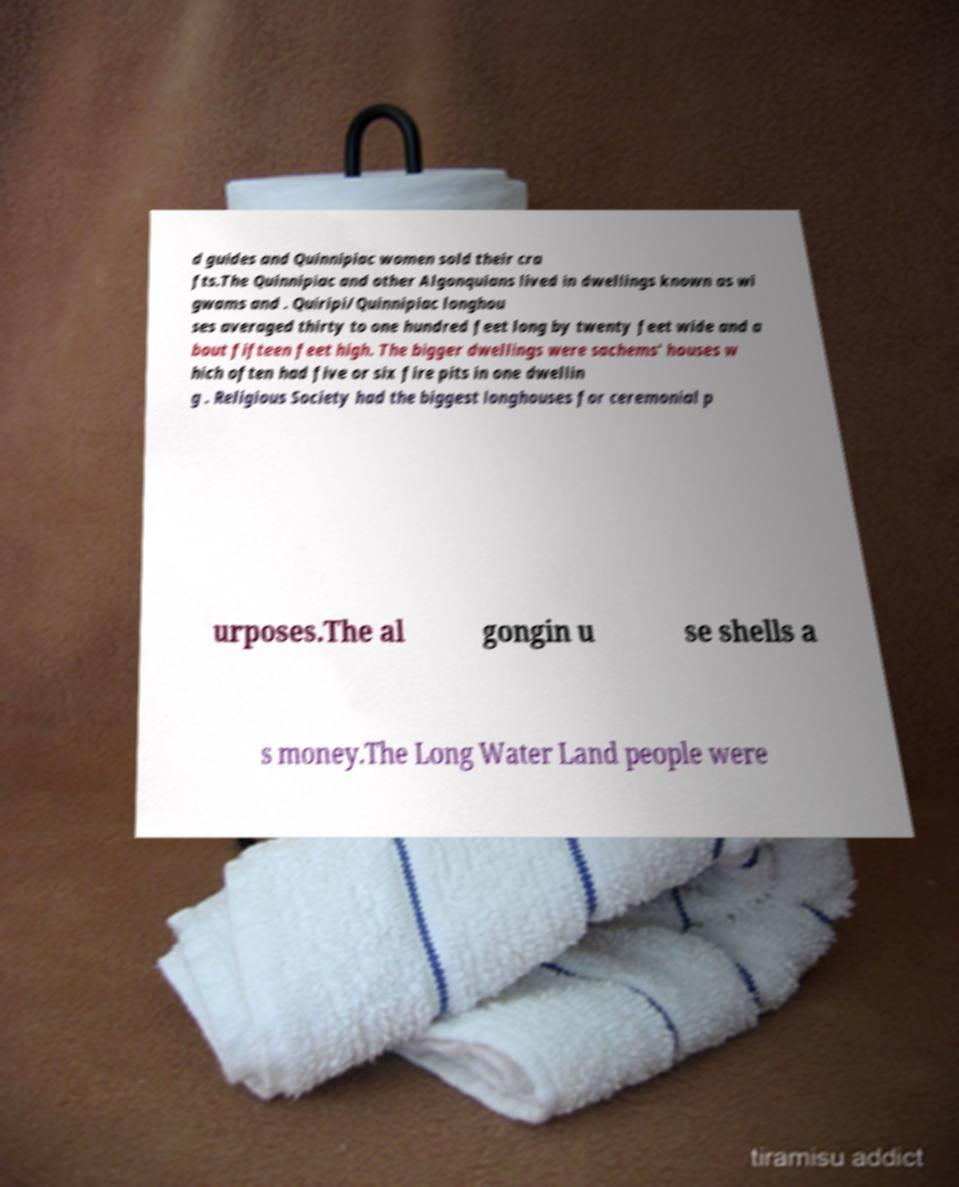For documentation purposes, I need the text within this image transcribed. Could you provide that? d guides and Quinnipiac women sold their cra fts.The Quinnipiac and other Algonquians lived in dwellings known as wi gwams and . Quiripi/Quinnipiac longhou ses averaged thirty to one hundred feet long by twenty feet wide and a bout fifteen feet high. The bigger dwellings were sachems' houses w hich often had five or six fire pits in one dwellin g . Religious Society had the biggest longhouses for ceremonial p urposes.The al gongin u se shells a s money.The Long Water Land people were 